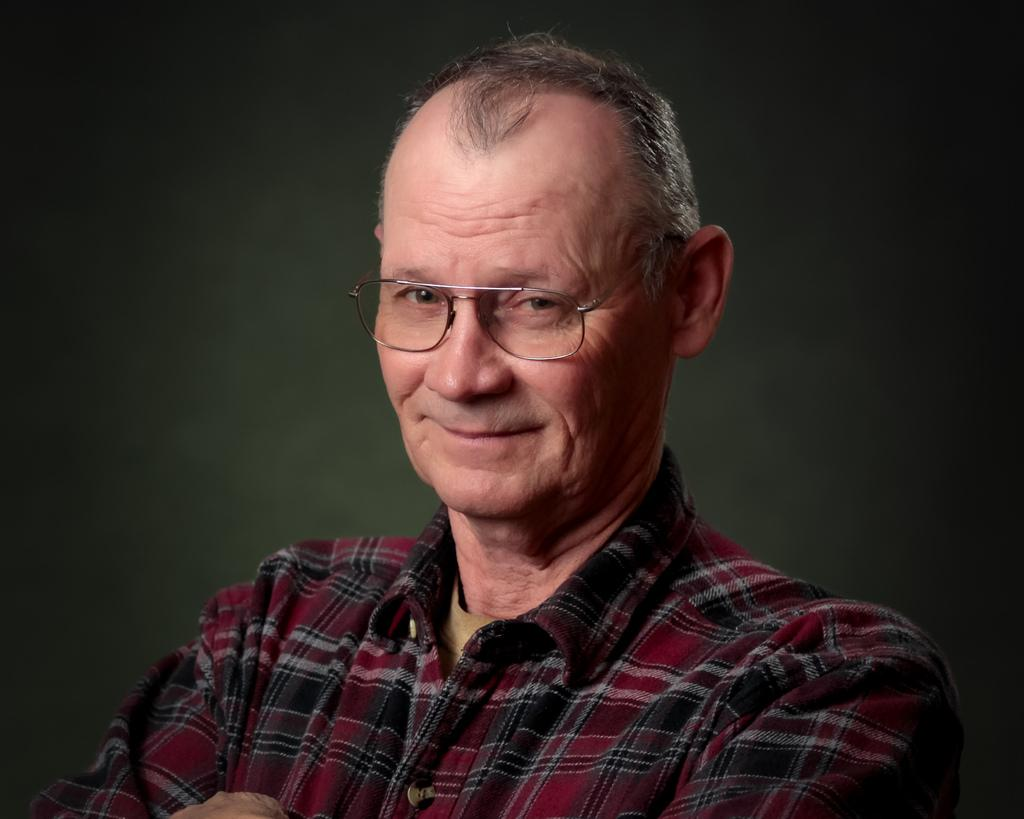What is the main subject of the image? There is a man in the center of the image. Can you describe the man's appearance? The man is wearing glasses. What type of instrument is the man playing in the image? There is no instrument present in the image; the man is simply standing there wearing glasses. What medical advice is the man providing in the image? There is no indication that the man is a doctor or providing medical advice in the image. 